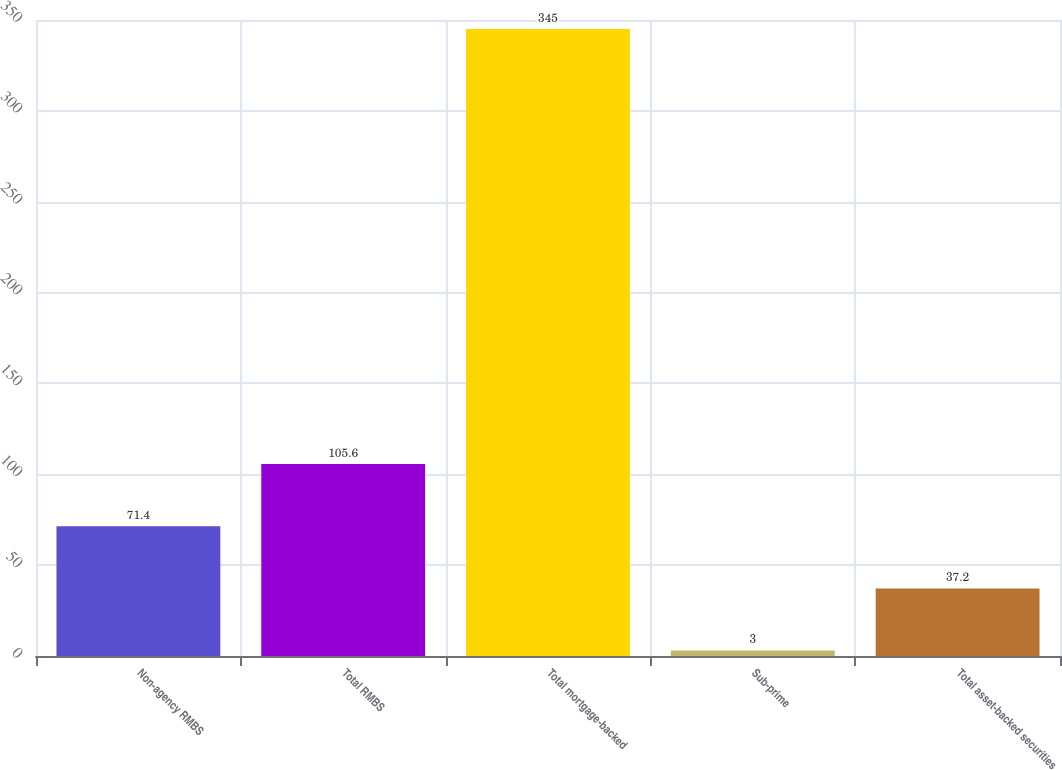Convert chart to OTSL. <chart><loc_0><loc_0><loc_500><loc_500><bar_chart><fcel>Non-agency RMBS<fcel>Total RMBS<fcel>Total mortgage-backed<fcel>Sub-prime<fcel>Total asset-backed securities<nl><fcel>71.4<fcel>105.6<fcel>345<fcel>3<fcel>37.2<nl></chart> 